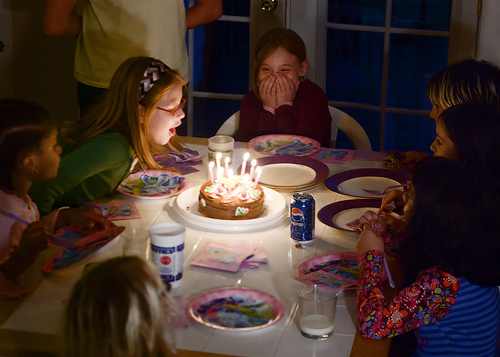<image>
Is there a girl to the left of the table? Yes. From this viewpoint, the girl is positioned to the left side relative to the table. 